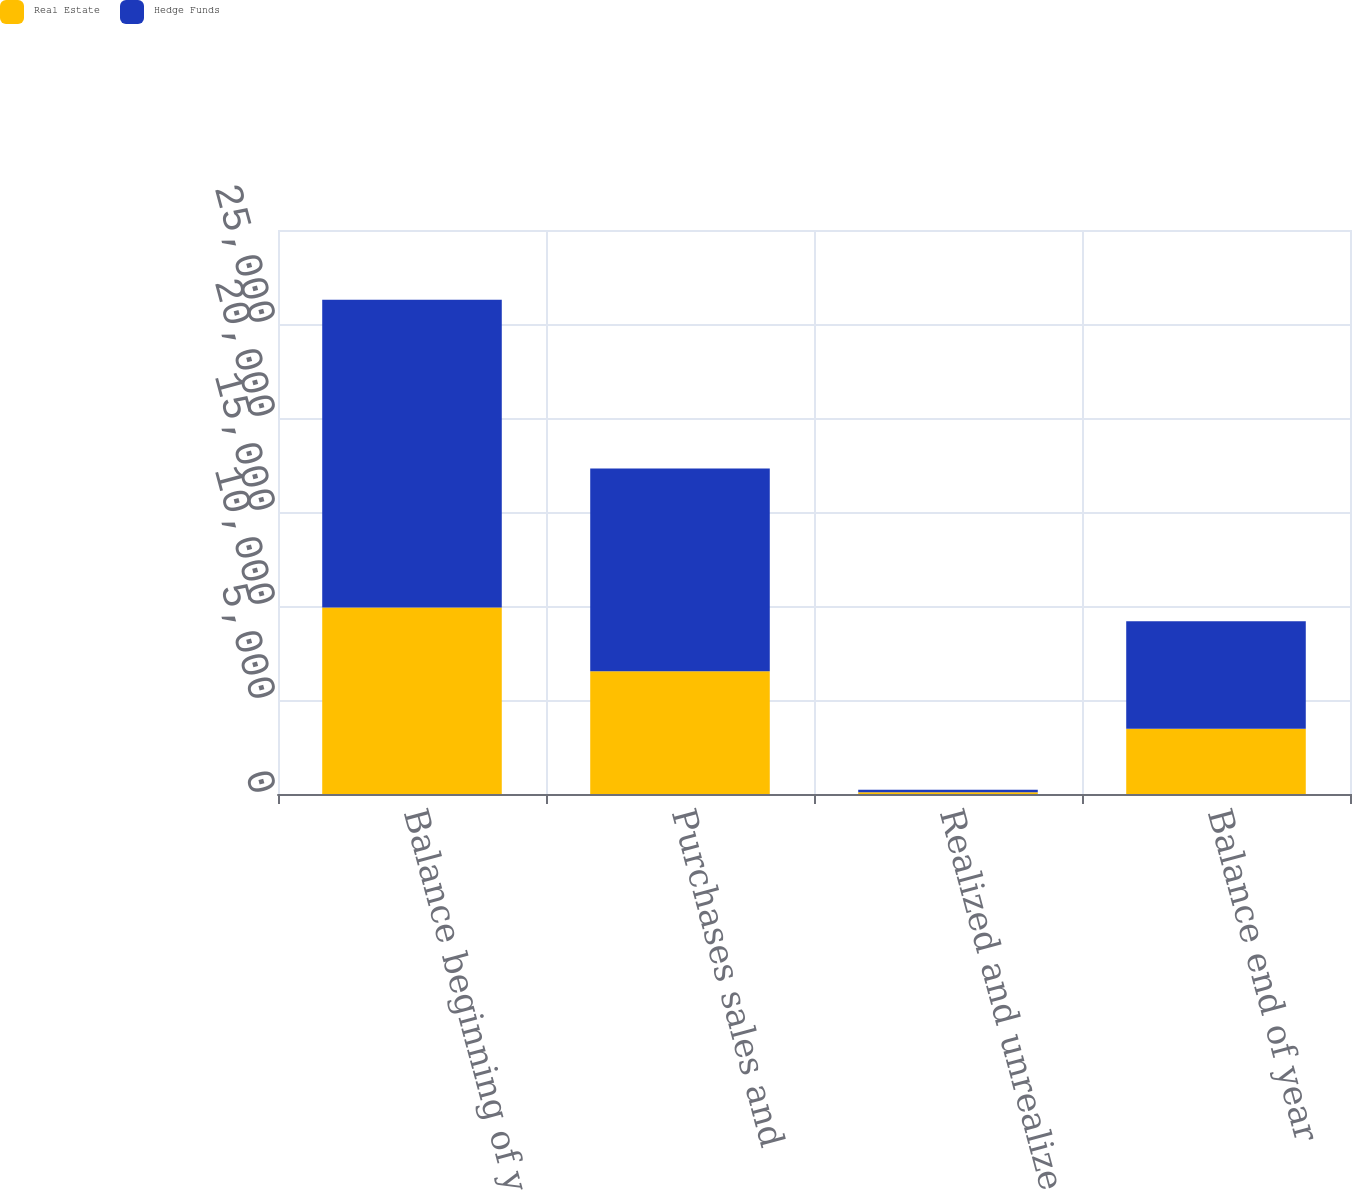<chart> <loc_0><loc_0><loc_500><loc_500><stacked_bar_chart><ecel><fcel>Balance beginning of year<fcel>Purchases sales and<fcel>Realized and unrealized gains<fcel>Balance end of year<nl><fcel>Real Estate<fcel>9914<fcel>6530<fcel>93<fcel>3477<nl><fcel>Hedge Funds<fcel>16372<fcel>10788<fcel>131<fcel>5715<nl></chart> 